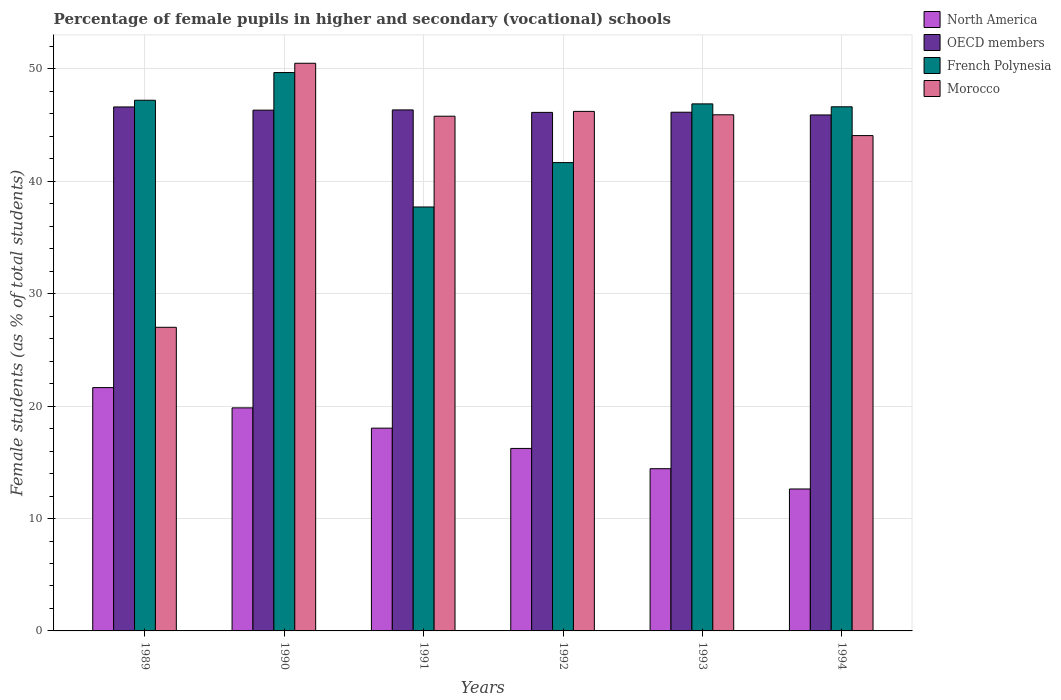How many different coloured bars are there?
Give a very brief answer. 4. How many groups of bars are there?
Make the answer very short. 6. How many bars are there on the 4th tick from the left?
Keep it short and to the point. 4. What is the percentage of female pupils in higher and secondary schools in Morocco in 1990?
Provide a short and direct response. 50.5. Across all years, what is the maximum percentage of female pupils in higher and secondary schools in Morocco?
Offer a terse response. 50.5. Across all years, what is the minimum percentage of female pupils in higher and secondary schools in OECD members?
Provide a succinct answer. 45.91. What is the total percentage of female pupils in higher and secondary schools in North America in the graph?
Your response must be concise. 102.83. What is the difference between the percentage of female pupils in higher and secondary schools in North America in 1991 and that in 1993?
Keep it short and to the point. 3.61. What is the difference between the percentage of female pupils in higher and secondary schools in North America in 1994 and the percentage of female pupils in higher and secondary schools in Morocco in 1990?
Give a very brief answer. -37.88. What is the average percentage of female pupils in higher and secondary schools in Morocco per year?
Make the answer very short. 43.25. In the year 1991, what is the difference between the percentage of female pupils in higher and secondary schools in OECD members and percentage of female pupils in higher and secondary schools in North America?
Offer a terse response. 28.31. What is the ratio of the percentage of female pupils in higher and secondary schools in French Polynesia in 1990 to that in 1993?
Provide a succinct answer. 1.06. Is the percentage of female pupils in higher and secondary schools in French Polynesia in 1990 less than that in 1991?
Your answer should be compact. No. Is the difference between the percentage of female pupils in higher and secondary schools in OECD members in 1991 and 1993 greater than the difference between the percentage of female pupils in higher and secondary schools in North America in 1991 and 1993?
Keep it short and to the point. No. What is the difference between the highest and the second highest percentage of female pupils in higher and secondary schools in Morocco?
Your answer should be very brief. 4.28. What is the difference between the highest and the lowest percentage of female pupils in higher and secondary schools in North America?
Offer a very short reply. 9.02. Is the sum of the percentage of female pupils in higher and secondary schools in OECD members in 1991 and 1994 greater than the maximum percentage of female pupils in higher and secondary schools in North America across all years?
Provide a short and direct response. Yes. What does the 4th bar from the left in 1994 represents?
Offer a very short reply. Morocco. What does the 4th bar from the right in 1993 represents?
Keep it short and to the point. North America. Are all the bars in the graph horizontal?
Provide a short and direct response. No. Where does the legend appear in the graph?
Provide a succinct answer. Top right. How are the legend labels stacked?
Offer a very short reply. Vertical. What is the title of the graph?
Give a very brief answer. Percentage of female pupils in higher and secondary (vocational) schools. Does "Malta" appear as one of the legend labels in the graph?
Provide a short and direct response. No. What is the label or title of the X-axis?
Make the answer very short. Years. What is the label or title of the Y-axis?
Keep it short and to the point. Female students (as % of total students). What is the Female students (as % of total students) in North America in 1989?
Your answer should be compact. 21.65. What is the Female students (as % of total students) in OECD members in 1989?
Provide a succinct answer. 46.62. What is the Female students (as % of total students) of French Polynesia in 1989?
Your answer should be compact. 47.21. What is the Female students (as % of total students) in Morocco in 1989?
Offer a very short reply. 27.01. What is the Female students (as % of total students) of North America in 1990?
Keep it short and to the point. 19.84. What is the Female students (as % of total students) of OECD members in 1990?
Your answer should be very brief. 46.33. What is the Female students (as % of total students) of French Polynesia in 1990?
Give a very brief answer. 49.68. What is the Female students (as % of total students) of Morocco in 1990?
Ensure brevity in your answer.  50.5. What is the Female students (as % of total students) in North America in 1991?
Ensure brevity in your answer.  18.04. What is the Female students (as % of total students) in OECD members in 1991?
Give a very brief answer. 46.35. What is the Female students (as % of total students) of French Polynesia in 1991?
Your answer should be very brief. 37.72. What is the Female students (as % of total students) of Morocco in 1991?
Keep it short and to the point. 45.79. What is the Female students (as % of total students) of North America in 1992?
Your response must be concise. 16.24. What is the Female students (as % of total students) in OECD members in 1992?
Your answer should be very brief. 46.13. What is the Female students (as % of total students) of French Polynesia in 1992?
Your response must be concise. 41.67. What is the Female students (as % of total students) in Morocco in 1992?
Your answer should be compact. 46.22. What is the Female students (as % of total students) in North America in 1993?
Provide a short and direct response. 14.43. What is the Female students (as % of total students) in OECD members in 1993?
Make the answer very short. 46.15. What is the Female students (as % of total students) in French Polynesia in 1993?
Ensure brevity in your answer.  46.89. What is the Female students (as % of total students) of Morocco in 1993?
Your answer should be compact. 45.92. What is the Female students (as % of total students) of North America in 1994?
Offer a terse response. 12.63. What is the Female students (as % of total students) in OECD members in 1994?
Your response must be concise. 45.91. What is the Female students (as % of total students) of French Polynesia in 1994?
Give a very brief answer. 46.63. What is the Female students (as % of total students) of Morocco in 1994?
Your response must be concise. 44.07. Across all years, what is the maximum Female students (as % of total students) in North America?
Your answer should be very brief. 21.65. Across all years, what is the maximum Female students (as % of total students) in OECD members?
Your response must be concise. 46.62. Across all years, what is the maximum Female students (as % of total students) of French Polynesia?
Your answer should be very brief. 49.68. Across all years, what is the maximum Female students (as % of total students) in Morocco?
Your response must be concise. 50.5. Across all years, what is the minimum Female students (as % of total students) in North America?
Offer a very short reply. 12.63. Across all years, what is the minimum Female students (as % of total students) in OECD members?
Offer a very short reply. 45.91. Across all years, what is the minimum Female students (as % of total students) in French Polynesia?
Give a very brief answer. 37.72. Across all years, what is the minimum Female students (as % of total students) in Morocco?
Offer a very short reply. 27.01. What is the total Female students (as % of total students) of North America in the graph?
Offer a very short reply. 102.83. What is the total Female students (as % of total students) in OECD members in the graph?
Your answer should be very brief. 277.49. What is the total Female students (as % of total students) in French Polynesia in the graph?
Your response must be concise. 269.8. What is the total Female students (as % of total students) in Morocco in the graph?
Provide a short and direct response. 259.53. What is the difference between the Female students (as % of total students) in North America in 1989 and that in 1990?
Your answer should be very brief. 1.8. What is the difference between the Female students (as % of total students) of OECD members in 1989 and that in 1990?
Offer a very short reply. 0.28. What is the difference between the Female students (as % of total students) in French Polynesia in 1989 and that in 1990?
Give a very brief answer. -2.46. What is the difference between the Female students (as % of total students) in Morocco in 1989 and that in 1990?
Make the answer very short. -23.49. What is the difference between the Female students (as % of total students) in North America in 1989 and that in 1991?
Your response must be concise. 3.61. What is the difference between the Female students (as % of total students) of OECD members in 1989 and that in 1991?
Your answer should be compact. 0.26. What is the difference between the Female students (as % of total students) of French Polynesia in 1989 and that in 1991?
Your response must be concise. 9.5. What is the difference between the Female students (as % of total students) in Morocco in 1989 and that in 1991?
Your response must be concise. -18.78. What is the difference between the Female students (as % of total students) in North America in 1989 and that in 1992?
Your answer should be compact. 5.41. What is the difference between the Female students (as % of total students) in OECD members in 1989 and that in 1992?
Your answer should be compact. 0.48. What is the difference between the Female students (as % of total students) in French Polynesia in 1989 and that in 1992?
Provide a short and direct response. 5.55. What is the difference between the Female students (as % of total students) of Morocco in 1989 and that in 1992?
Keep it short and to the point. -19.21. What is the difference between the Female students (as % of total students) in North America in 1989 and that in 1993?
Keep it short and to the point. 7.22. What is the difference between the Female students (as % of total students) in OECD members in 1989 and that in 1993?
Ensure brevity in your answer.  0.47. What is the difference between the Female students (as % of total students) of French Polynesia in 1989 and that in 1993?
Give a very brief answer. 0.32. What is the difference between the Female students (as % of total students) in Morocco in 1989 and that in 1993?
Offer a very short reply. -18.91. What is the difference between the Female students (as % of total students) of North America in 1989 and that in 1994?
Give a very brief answer. 9.02. What is the difference between the Female students (as % of total students) of OECD members in 1989 and that in 1994?
Give a very brief answer. 0.71. What is the difference between the Female students (as % of total students) of French Polynesia in 1989 and that in 1994?
Ensure brevity in your answer.  0.58. What is the difference between the Female students (as % of total students) of Morocco in 1989 and that in 1994?
Give a very brief answer. -17.06. What is the difference between the Female students (as % of total students) of North America in 1990 and that in 1991?
Provide a short and direct response. 1.8. What is the difference between the Female students (as % of total students) of OECD members in 1990 and that in 1991?
Give a very brief answer. -0.02. What is the difference between the Female students (as % of total students) in French Polynesia in 1990 and that in 1991?
Your answer should be compact. 11.96. What is the difference between the Female students (as % of total students) of Morocco in 1990 and that in 1991?
Offer a very short reply. 4.71. What is the difference between the Female students (as % of total students) in North America in 1990 and that in 1992?
Offer a very short reply. 3.61. What is the difference between the Female students (as % of total students) in OECD members in 1990 and that in 1992?
Offer a very short reply. 0.2. What is the difference between the Female students (as % of total students) of French Polynesia in 1990 and that in 1992?
Offer a terse response. 8.01. What is the difference between the Female students (as % of total students) of Morocco in 1990 and that in 1992?
Your answer should be very brief. 4.28. What is the difference between the Female students (as % of total students) of North America in 1990 and that in 1993?
Provide a succinct answer. 5.41. What is the difference between the Female students (as % of total students) in OECD members in 1990 and that in 1993?
Provide a succinct answer. 0.19. What is the difference between the Female students (as % of total students) of French Polynesia in 1990 and that in 1993?
Keep it short and to the point. 2.79. What is the difference between the Female students (as % of total students) of Morocco in 1990 and that in 1993?
Keep it short and to the point. 4.58. What is the difference between the Female students (as % of total students) of North America in 1990 and that in 1994?
Offer a terse response. 7.22. What is the difference between the Female students (as % of total students) of OECD members in 1990 and that in 1994?
Provide a succinct answer. 0.43. What is the difference between the Female students (as % of total students) of French Polynesia in 1990 and that in 1994?
Your response must be concise. 3.04. What is the difference between the Female students (as % of total students) in Morocco in 1990 and that in 1994?
Provide a short and direct response. 6.43. What is the difference between the Female students (as % of total students) in North America in 1991 and that in 1992?
Offer a very short reply. 1.8. What is the difference between the Female students (as % of total students) of OECD members in 1991 and that in 1992?
Ensure brevity in your answer.  0.22. What is the difference between the Female students (as % of total students) in French Polynesia in 1991 and that in 1992?
Provide a short and direct response. -3.95. What is the difference between the Female students (as % of total students) of Morocco in 1991 and that in 1992?
Offer a terse response. -0.43. What is the difference between the Female students (as % of total students) in North America in 1991 and that in 1993?
Give a very brief answer. 3.61. What is the difference between the Female students (as % of total students) of OECD members in 1991 and that in 1993?
Provide a short and direct response. 0.21. What is the difference between the Female students (as % of total students) of French Polynesia in 1991 and that in 1993?
Your answer should be compact. -9.17. What is the difference between the Female students (as % of total students) in Morocco in 1991 and that in 1993?
Provide a succinct answer. -0.13. What is the difference between the Female students (as % of total students) of North America in 1991 and that in 1994?
Make the answer very short. 5.41. What is the difference between the Female students (as % of total students) of OECD members in 1991 and that in 1994?
Your response must be concise. 0.45. What is the difference between the Female students (as % of total students) of French Polynesia in 1991 and that in 1994?
Your answer should be compact. -8.91. What is the difference between the Female students (as % of total students) in Morocco in 1991 and that in 1994?
Give a very brief answer. 1.72. What is the difference between the Female students (as % of total students) in North America in 1992 and that in 1993?
Ensure brevity in your answer.  1.8. What is the difference between the Female students (as % of total students) in OECD members in 1992 and that in 1993?
Provide a short and direct response. -0.01. What is the difference between the Female students (as % of total students) in French Polynesia in 1992 and that in 1993?
Provide a short and direct response. -5.22. What is the difference between the Female students (as % of total students) in Morocco in 1992 and that in 1993?
Your response must be concise. 0.3. What is the difference between the Female students (as % of total students) of North America in 1992 and that in 1994?
Your response must be concise. 3.61. What is the difference between the Female students (as % of total students) in OECD members in 1992 and that in 1994?
Make the answer very short. 0.23. What is the difference between the Female students (as % of total students) of French Polynesia in 1992 and that in 1994?
Give a very brief answer. -4.97. What is the difference between the Female students (as % of total students) of Morocco in 1992 and that in 1994?
Give a very brief answer. 2.15. What is the difference between the Female students (as % of total students) of North America in 1993 and that in 1994?
Keep it short and to the point. 1.8. What is the difference between the Female students (as % of total students) of OECD members in 1993 and that in 1994?
Offer a terse response. 0.24. What is the difference between the Female students (as % of total students) in French Polynesia in 1993 and that in 1994?
Keep it short and to the point. 0.26. What is the difference between the Female students (as % of total students) in Morocco in 1993 and that in 1994?
Your answer should be compact. 1.85. What is the difference between the Female students (as % of total students) of North America in 1989 and the Female students (as % of total students) of OECD members in 1990?
Provide a short and direct response. -24.68. What is the difference between the Female students (as % of total students) of North America in 1989 and the Female students (as % of total students) of French Polynesia in 1990?
Your answer should be very brief. -28.03. What is the difference between the Female students (as % of total students) in North America in 1989 and the Female students (as % of total students) in Morocco in 1990?
Provide a short and direct response. -28.86. What is the difference between the Female students (as % of total students) of OECD members in 1989 and the Female students (as % of total students) of French Polynesia in 1990?
Your response must be concise. -3.06. What is the difference between the Female students (as % of total students) in OECD members in 1989 and the Female students (as % of total students) in Morocco in 1990?
Your response must be concise. -3.89. What is the difference between the Female students (as % of total students) in French Polynesia in 1989 and the Female students (as % of total students) in Morocco in 1990?
Your answer should be very brief. -3.29. What is the difference between the Female students (as % of total students) in North America in 1989 and the Female students (as % of total students) in OECD members in 1991?
Your answer should be very brief. -24.7. What is the difference between the Female students (as % of total students) of North America in 1989 and the Female students (as % of total students) of French Polynesia in 1991?
Ensure brevity in your answer.  -16.07. What is the difference between the Female students (as % of total students) of North America in 1989 and the Female students (as % of total students) of Morocco in 1991?
Provide a short and direct response. -24.14. What is the difference between the Female students (as % of total students) of OECD members in 1989 and the Female students (as % of total students) of French Polynesia in 1991?
Ensure brevity in your answer.  8.9. What is the difference between the Female students (as % of total students) of OECD members in 1989 and the Female students (as % of total students) of Morocco in 1991?
Your answer should be compact. 0.82. What is the difference between the Female students (as % of total students) of French Polynesia in 1989 and the Female students (as % of total students) of Morocco in 1991?
Offer a terse response. 1.42. What is the difference between the Female students (as % of total students) of North America in 1989 and the Female students (as % of total students) of OECD members in 1992?
Give a very brief answer. -24.49. What is the difference between the Female students (as % of total students) in North America in 1989 and the Female students (as % of total students) in French Polynesia in 1992?
Offer a very short reply. -20.02. What is the difference between the Female students (as % of total students) in North America in 1989 and the Female students (as % of total students) in Morocco in 1992?
Your answer should be compact. -24.57. What is the difference between the Female students (as % of total students) in OECD members in 1989 and the Female students (as % of total students) in French Polynesia in 1992?
Your answer should be very brief. 4.95. What is the difference between the Female students (as % of total students) in OECD members in 1989 and the Female students (as % of total students) in Morocco in 1992?
Keep it short and to the point. 0.39. What is the difference between the Female students (as % of total students) of French Polynesia in 1989 and the Female students (as % of total students) of Morocco in 1992?
Your response must be concise. 0.99. What is the difference between the Female students (as % of total students) in North America in 1989 and the Female students (as % of total students) in OECD members in 1993?
Make the answer very short. -24.5. What is the difference between the Female students (as % of total students) of North America in 1989 and the Female students (as % of total students) of French Polynesia in 1993?
Offer a terse response. -25.24. What is the difference between the Female students (as % of total students) of North America in 1989 and the Female students (as % of total students) of Morocco in 1993?
Provide a short and direct response. -24.27. What is the difference between the Female students (as % of total students) in OECD members in 1989 and the Female students (as % of total students) in French Polynesia in 1993?
Offer a very short reply. -0.27. What is the difference between the Female students (as % of total students) in OECD members in 1989 and the Female students (as % of total students) in Morocco in 1993?
Provide a short and direct response. 0.7. What is the difference between the Female students (as % of total students) in French Polynesia in 1989 and the Female students (as % of total students) in Morocco in 1993?
Offer a very short reply. 1.29. What is the difference between the Female students (as % of total students) in North America in 1989 and the Female students (as % of total students) in OECD members in 1994?
Your answer should be very brief. -24.26. What is the difference between the Female students (as % of total students) of North America in 1989 and the Female students (as % of total students) of French Polynesia in 1994?
Keep it short and to the point. -24.98. What is the difference between the Female students (as % of total students) in North America in 1989 and the Female students (as % of total students) in Morocco in 1994?
Offer a terse response. -22.42. What is the difference between the Female students (as % of total students) of OECD members in 1989 and the Female students (as % of total students) of French Polynesia in 1994?
Your response must be concise. -0.01. What is the difference between the Female students (as % of total students) in OECD members in 1989 and the Female students (as % of total students) in Morocco in 1994?
Make the answer very short. 2.55. What is the difference between the Female students (as % of total students) in French Polynesia in 1989 and the Female students (as % of total students) in Morocco in 1994?
Provide a short and direct response. 3.14. What is the difference between the Female students (as % of total students) of North America in 1990 and the Female students (as % of total students) of OECD members in 1991?
Make the answer very short. -26.51. What is the difference between the Female students (as % of total students) of North America in 1990 and the Female students (as % of total students) of French Polynesia in 1991?
Offer a terse response. -17.87. What is the difference between the Female students (as % of total students) of North America in 1990 and the Female students (as % of total students) of Morocco in 1991?
Make the answer very short. -25.95. What is the difference between the Female students (as % of total students) of OECD members in 1990 and the Female students (as % of total students) of French Polynesia in 1991?
Your answer should be compact. 8.62. What is the difference between the Female students (as % of total students) in OECD members in 1990 and the Female students (as % of total students) in Morocco in 1991?
Make the answer very short. 0.54. What is the difference between the Female students (as % of total students) in French Polynesia in 1990 and the Female students (as % of total students) in Morocco in 1991?
Your response must be concise. 3.88. What is the difference between the Female students (as % of total students) of North America in 1990 and the Female students (as % of total students) of OECD members in 1992?
Make the answer very short. -26.29. What is the difference between the Female students (as % of total students) of North America in 1990 and the Female students (as % of total students) of French Polynesia in 1992?
Ensure brevity in your answer.  -21.82. What is the difference between the Female students (as % of total students) in North America in 1990 and the Female students (as % of total students) in Morocco in 1992?
Offer a very short reply. -26.38. What is the difference between the Female students (as % of total students) of OECD members in 1990 and the Female students (as % of total students) of French Polynesia in 1992?
Offer a terse response. 4.67. What is the difference between the Female students (as % of total students) of OECD members in 1990 and the Female students (as % of total students) of Morocco in 1992?
Your response must be concise. 0.11. What is the difference between the Female students (as % of total students) of French Polynesia in 1990 and the Female students (as % of total students) of Morocco in 1992?
Offer a very short reply. 3.45. What is the difference between the Female students (as % of total students) in North America in 1990 and the Female students (as % of total students) in OECD members in 1993?
Your response must be concise. -26.3. What is the difference between the Female students (as % of total students) in North America in 1990 and the Female students (as % of total students) in French Polynesia in 1993?
Make the answer very short. -27.05. What is the difference between the Female students (as % of total students) in North America in 1990 and the Female students (as % of total students) in Morocco in 1993?
Keep it short and to the point. -26.08. What is the difference between the Female students (as % of total students) of OECD members in 1990 and the Female students (as % of total students) of French Polynesia in 1993?
Offer a very short reply. -0.56. What is the difference between the Female students (as % of total students) in OECD members in 1990 and the Female students (as % of total students) in Morocco in 1993?
Give a very brief answer. 0.41. What is the difference between the Female students (as % of total students) of French Polynesia in 1990 and the Female students (as % of total students) of Morocco in 1993?
Offer a terse response. 3.76. What is the difference between the Female students (as % of total students) in North America in 1990 and the Female students (as % of total students) in OECD members in 1994?
Make the answer very short. -26.06. What is the difference between the Female students (as % of total students) of North America in 1990 and the Female students (as % of total students) of French Polynesia in 1994?
Your answer should be compact. -26.79. What is the difference between the Female students (as % of total students) in North America in 1990 and the Female students (as % of total students) in Morocco in 1994?
Make the answer very short. -24.23. What is the difference between the Female students (as % of total students) in OECD members in 1990 and the Female students (as % of total students) in French Polynesia in 1994?
Provide a succinct answer. -0.3. What is the difference between the Female students (as % of total students) of OECD members in 1990 and the Female students (as % of total students) of Morocco in 1994?
Ensure brevity in your answer.  2.26. What is the difference between the Female students (as % of total students) of French Polynesia in 1990 and the Female students (as % of total students) of Morocco in 1994?
Offer a terse response. 5.61. What is the difference between the Female students (as % of total students) in North America in 1991 and the Female students (as % of total students) in OECD members in 1992?
Your answer should be compact. -28.09. What is the difference between the Female students (as % of total students) in North America in 1991 and the Female students (as % of total students) in French Polynesia in 1992?
Make the answer very short. -23.63. What is the difference between the Female students (as % of total students) of North America in 1991 and the Female students (as % of total students) of Morocco in 1992?
Keep it short and to the point. -28.18. What is the difference between the Female students (as % of total students) in OECD members in 1991 and the Female students (as % of total students) in French Polynesia in 1992?
Offer a terse response. 4.69. What is the difference between the Female students (as % of total students) in OECD members in 1991 and the Female students (as % of total students) in Morocco in 1992?
Give a very brief answer. 0.13. What is the difference between the Female students (as % of total students) in French Polynesia in 1991 and the Female students (as % of total students) in Morocco in 1992?
Your answer should be compact. -8.51. What is the difference between the Female students (as % of total students) of North America in 1991 and the Female students (as % of total students) of OECD members in 1993?
Your answer should be compact. -28.11. What is the difference between the Female students (as % of total students) in North America in 1991 and the Female students (as % of total students) in French Polynesia in 1993?
Give a very brief answer. -28.85. What is the difference between the Female students (as % of total students) in North America in 1991 and the Female students (as % of total students) in Morocco in 1993?
Offer a very short reply. -27.88. What is the difference between the Female students (as % of total students) of OECD members in 1991 and the Female students (as % of total students) of French Polynesia in 1993?
Provide a short and direct response. -0.54. What is the difference between the Female students (as % of total students) of OECD members in 1991 and the Female students (as % of total students) of Morocco in 1993?
Keep it short and to the point. 0.43. What is the difference between the Female students (as % of total students) of French Polynesia in 1991 and the Female students (as % of total students) of Morocco in 1993?
Provide a short and direct response. -8.2. What is the difference between the Female students (as % of total students) of North America in 1991 and the Female students (as % of total students) of OECD members in 1994?
Your response must be concise. -27.86. What is the difference between the Female students (as % of total students) in North America in 1991 and the Female students (as % of total students) in French Polynesia in 1994?
Ensure brevity in your answer.  -28.59. What is the difference between the Female students (as % of total students) in North America in 1991 and the Female students (as % of total students) in Morocco in 1994?
Your answer should be very brief. -26.03. What is the difference between the Female students (as % of total students) of OECD members in 1991 and the Female students (as % of total students) of French Polynesia in 1994?
Your answer should be very brief. -0.28. What is the difference between the Female students (as % of total students) in OECD members in 1991 and the Female students (as % of total students) in Morocco in 1994?
Keep it short and to the point. 2.28. What is the difference between the Female students (as % of total students) in French Polynesia in 1991 and the Female students (as % of total students) in Morocco in 1994?
Provide a short and direct response. -6.35. What is the difference between the Female students (as % of total students) of North America in 1992 and the Female students (as % of total students) of OECD members in 1993?
Make the answer very short. -29.91. What is the difference between the Female students (as % of total students) of North America in 1992 and the Female students (as % of total students) of French Polynesia in 1993?
Ensure brevity in your answer.  -30.65. What is the difference between the Female students (as % of total students) in North America in 1992 and the Female students (as % of total students) in Morocco in 1993?
Offer a terse response. -29.68. What is the difference between the Female students (as % of total students) in OECD members in 1992 and the Female students (as % of total students) in French Polynesia in 1993?
Ensure brevity in your answer.  -0.76. What is the difference between the Female students (as % of total students) in OECD members in 1992 and the Female students (as % of total students) in Morocco in 1993?
Ensure brevity in your answer.  0.21. What is the difference between the Female students (as % of total students) of French Polynesia in 1992 and the Female students (as % of total students) of Morocco in 1993?
Your answer should be very brief. -4.25. What is the difference between the Female students (as % of total students) in North America in 1992 and the Female students (as % of total students) in OECD members in 1994?
Make the answer very short. -29.67. What is the difference between the Female students (as % of total students) in North America in 1992 and the Female students (as % of total students) in French Polynesia in 1994?
Provide a succinct answer. -30.4. What is the difference between the Female students (as % of total students) in North America in 1992 and the Female students (as % of total students) in Morocco in 1994?
Give a very brief answer. -27.83. What is the difference between the Female students (as % of total students) in OECD members in 1992 and the Female students (as % of total students) in French Polynesia in 1994?
Ensure brevity in your answer.  -0.5. What is the difference between the Female students (as % of total students) of OECD members in 1992 and the Female students (as % of total students) of Morocco in 1994?
Provide a succinct answer. 2.06. What is the difference between the Female students (as % of total students) of French Polynesia in 1992 and the Female students (as % of total students) of Morocco in 1994?
Keep it short and to the point. -2.4. What is the difference between the Female students (as % of total students) in North America in 1993 and the Female students (as % of total students) in OECD members in 1994?
Provide a short and direct response. -31.47. What is the difference between the Female students (as % of total students) in North America in 1993 and the Female students (as % of total students) in French Polynesia in 1994?
Offer a very short reply. -32.2. What is the difference between the Female students (as % of total students) in North America in 1993 and the Female students (as % of total students) in Morocco in 1994?
Keep it short and to the point. -29.64. What is the difference between the Female students (as % of total students) of OECD members in 1993 and the Female students (as % of total students) of French Polynesia in 1994?
Keep it short and to the point. -0.48. What is the difference between the Female students (as % of total students) of OECD members in 1993 and the Female students (as % of total students) of Morocco in 1994?
Make the answer very short. 2.08. What is the difference between the Female students (as % of total students) in French Polynesia in 1993 and the Female students (as % of total students) in Morocco in 1994?
Provide a short and direct response. 2.82. What is the average Female students (as % of total students) in North America per year?
Keep it short and to the point. 17.14. What is the average Female students (as % of total students) of OECD members per year?
Provide a succinct answer. 46.25. What is the average Female students (as % of total students) in French Polynesia per year?
Provide a short and direct response. 44.97. What is the average Female students (as % of total students) of Morocco per year?
Offer a terse response. 43.25. In the year 1989, what is the difference between the Female students (as % of total students) in North America and Female students (as % of total students) in OECD members?
Your answer should be very brief. -24.97. In the year 1989, what is the difference between the Female students (as % of total students) of North America and Female students (as % of total students) of French Polynesia?
Offer a very short reply. -25.57. In the year 1989, what is the difference between the Female students (as % of total students) in North America and Female students (as % of total students) in Morocco?
Your answer should be compact. -5.36. In the year 1989, what is the difference between the Female students (as % of total students) in OECD members and Female students (as % of total students) in French Polynesia?
Your answer should be very brief. -0.6. In the year 1989, what is the difference between the Female students (as % of total students) of OECD members and Female students (as % of total students) of Morocco?
Your response must be concise. 19.6. In the year 1989, what is the difference between the Female students (as % of total students) of French Polynesia and Female students (as % of total students) of Morocco?
Your response must be concise. 20.2. In the year 1990, what is the difference between the Female students (as % of total students) of North America and Female students (as % of total students) of OECD members?
Make the answer very short. -26.49. In the year 1990, what is the difference between the Female students (as % of total students) in North America and Female students (as % of total students) in French Polynesia?
Your answer should be very brief. -29.83. In the year 1990, what is the difference between the Female students (as % of total students) in North America and Female students (as % of total students) in Morocco?
Your response must be concise. -30.66. In the year 1990, what is the difference between the Female students (as % of total students) of OECD members and Female students (as % of total students) of French Polynesia?
Offer a terse response. -3.34. In the year 1990, what is the difference between the Female students (as % of total students) in OECD members and Female students (as % of total students) in Morocco?
Provide a succinct answer. -4.17. In the year 1990, what is the difference between the Female students (as % of total students) of French Polynesia and Female students (as % of total students) of Morocco?
Your response must be concise. -0.83. In the year 1991, what is the difference between the Female students (as % of total students) of North America and Female students (as % of total students) of OECD members?
Your response must be concise. -28.31. In the year 1991, what is the difference between the Female students (as % of total students) in North America and Female students (as % of total students) in French Polynesia?
Give a very brief answer. -19.68. In the year 1991, what is the difference between the Female students (as % of total students) of North America and Female students (as % of total students) of Morocco?
Your answer should be very brief. -27.75. In the year 1991, what is the difference between the Female students (as % of total students) of OECD members and Female students (as % of total students) of French Polynesia?
Your answer should be compact. 8.64. In the year 1991, what is the difference between the Female students (as % of total students) of OECD members and Female students (as % of total students) of Morocco?
Your answer should be compact. 0.56. In the year 1991, what is the difference between the Female students (as % of total students) in French Polynesia and Female students (as % of total students) in Morocco?
Offer a very short reply. -8.08. In the year 1992, what is the difference between the Female students (as % of total students) in North America and Female students (as % of total students) in OECD members?
Your answer should be compact. -29.9. In the year 1992, what is the difference between the Female students (as % of total students) in North America and Female students (as % of total students) in French Polynesia?
Offer a terse response. -25.43. In the year 1992, what is the difference between the Female students (as % of total students) of North America and Female students (as % of total students) of Morocco?
Keep it short and to the point. -29.99. In the year 1992, what is the difference between the Female students (as % of total students) of OECD members and Female students (as % of total students) of French Polynesia?
Your answer should be compact. 4.47. In the year 1992, what is the difference between the Female students (as % of total students) of OECD members and Female students (as % of total students) of Morocco?
Ensure brevity in your answer.  -0.09. In the year 1992, what is the difference between the Female students (as % of total students) of French Polynesia and Female students (as % of total students) of Morocco?
Keep it short and to the point. -4.56. In the year 1993, what is the difference between the Female students (as % of total students) of North America and Female students (as % of total students) of OECD members?
Your answer should be compact. -31.71. In the year 1993, what is the difference between the Female students (as % of total students) of North America and Female students (as % of total students) of French Polynesia?
Ensure brevity in your answer.  -32.46. In the year 1993, what is the difference between the Female students (as % of total students) in North America and Female students (as % of total students) in Morocco?
Make the answer very short. -31.49. In the year 1993, what is the difference between the Female students (as % of total students) in OECD members and Female students (as % of total students) in French Polynesia?
Give a very brief answer. -0.74. In the year 1993, what is the difference between the Female students (as % of total students) in OECD members and Female students (as % of total students) in Morocco?
Give a very brief answer. 0.23. In the year 1993, what is the difference between the Female students (as % of total students) of French Polynesia and Female students (as % of total students) of Morocco?
Make the answer very short. 0.97. In the year 1994, what is the difference between the Female students (as % of total students) of North America and Female students (as % of total students) of OECD members?
Offer a very short reply. -33.28. In the year 1994, what is the difference between the Female students (as % of total students) in North America and Female students (as % of total students) in French Polynesia?
Your response must be concise. -34. In the year 1994, what is the difference between the Female students (as % of total students) of North America and Female students (as % of total students) of Morocco?
Keep it short and to the point. -31.44. In the year 1994, what is the difference between the Female students (as % of total students) of OECD members and Female students (as % of total students) of French Polynesia?
Your answer should be compact. -0.73. In the year 1994, what is the difference between the Female students (as % of total students) of OECD members and Female students (as % of total students) of Morocco?
Provide a succinct answer. 1.84. In the year 1994, what is the difference between the Female students (as % of total students) in French Polynesia and Female students (as % of total students) in Morocco?
Keep it short and to the point. 2.56. What is the ratio of the Female students (as % of total students) in OECD members in 1989 to that in 1990?
Provide a short and direct response. 1.01. What is the ratio of the Female students (as % of total students) in French Polynesia in 1989 to that in 1990?
Ensure brevity in your answer.  0.95. What is the ratio of the Female students (as % of total students) in Morocco in 1989 to that in 1990?
Provide a succinct answer. 0.53. What is the ratio of the Female students (as % of total students) in French Polynesia in 1989 to that in 1991?
Offer a very short reply. 1.25. What is the ratio of the Female students (as % of total students) in Morocco in 1989 to that in 1991?
Offer a terse response. 0.59. What is the ratio of the Female students (as % of total students) of OECD members in 1989 to that in 1992?
Keep it short and to the point. 1.01. What is the ratio of the Female students (as % of total students) of French Polynesia in 1989 to that in 1992?
Offer a very short reply. 1.13. What is the ratio of the Female students (as % of total students) of Morocco in 1989 to that in 1992?
Offer a very short reply. 0.58. What is the ratio of the Female students (as % of total students) of North America in 1989 to that in 1993?
Ensure brevity in your answer.  1.5. What is the ratio of the Female students (as % of total students) of OECD members in 1989 to that in 1993?
Make the answer very short. 1.01. What is the ratio of the Female students (as % of total students) in French Polynesia in 1989 to that in 1993?
Keep it short and to the point. 1.01. What is the ratio of the Female students (as % of total students) in Morocco in 1989 to that in 1993?
Provide a succinct answer. 0.59. What is the ratio of the Female students (as % of total students) of North America in 1989 to that in 1994?
Provide a short and direct response. 1.71. What is the ratio of the Female students (as % of total students) in OECD members in 1989 to that in 1994?
Offer a terse response. 1.02. What is the ratio of the Female students (as % of total students) in French Polynesia in 1989 to that in 1994?
Offer a terse response. 1.01. What is the ratio of the Female students (as % of total students) in Morocco in 1989 to that in 1994?
Your answer should be compact. 0.61. What is the ratio of the Female students (as % of total students) in French Polynesia in 1990 to that in 1991?
Your answer should be compact. 1.32. What is the ratio of the Female students (as % of total students) of Morocco in 1990 to that in 1991?
Ensure brevity in your answer.  1.1. What is the ratio of the Female students (as % of total students) of North America in 1990 to that in 1992?
Give a very brief answer. 1.22. What is the ratio of the Female students (as % of total students) of OECD members in 1990 to that in 1992?
Offer a terse response. 1. What is the ratio of the Female students (as % of total students) in French Polynesia in 1990 to that in 1992?
Your answer should be very brief. 1.19. What is the ratio of the Female students (as % of total students) of Morocco in 1990 to that in 1992?
Your response must be concise. 1.09. What is the ratio of the Female students (as % of total students) of North America in 1990 to that in 1993?
Keep it short and to the point. 1.38. What is the ratio of the Female students (as % of total students) of French Polynesia in 1990 to that in 1993?
Give a very brief answer. 1.06. What is the ratio of the Female students (as % of total students) of Morocco in 1990 to that in 1993?
Keep it short and to the point. 1.1. What is the ratio of the Female students (as % of total students) in North America in 1990 to that in 1994?
Your answer should be compact. 1.57. What is the ratio of the Female students (as % of total students) of OECD members in 1990 to that in 1994?
Your response must be concise. 1.01. What is the ratio of the Female students (as % of total students) of French Polynesia in 1990 to that in 1994?
Your answer should be very brief. 1.07. What is the ratio of the Female students (as % of total students) in Morocco in 1990 to that in 1994?
Offer a very short reply. 1.15. What is the ratio of the Female students (as % of total students) of OECD members in 1991 to that in 1992?
Give a very brief answer. 1. What is the ratio of the Female students (as % of total students) of French Polynesia in 1991 to that in 1992?
Your answer should be compact. 0.91. What is the ratio of the Female students (as % of total students) of OECD members in 1991 to that in 1993?
Make the answer very short. 1. What is the ratio of the Female students (as % of total students) of French Polynesia in 1991 to that in 1993?
Your answer should be very brief. 0.8. What is the ratio of the Female students (as % of total students) of Morocco in 1991 to that in 1993?
Provide a succinct answer. 1. What is the ratio of the Female students (as % of total students) of North America in 1991 to that in 1994?
Provide a short and direct response. 1.43. What is the ratio of the Female students (as % of total students) in OECD members in 1991 to that in 1994?
Provide a short and direct response. 1.01. What is the ratio of the Female students (as % of total students) of French Polynesia in 1991 to that in 1994?
Ensure brevity in your answer.  0.81. What is the ratio of the Female students (as % of total students) of Morocco in 1991 to that in 1994?
Keep it short and to the point. 1.04. What is the ratio of the Female students (as % of total students) of North America in 1992 to that in 1993?
Ensure brevity in your answer.  1.12. What is the ratio of the Female students (as % of total students) in French Polynesia in 1992 to that in 1993?
Provide a short and direct response. 0.89. What is the ratio of the Female students (as % of total students) of Morocco in 1992 to that in 1993?
Offer a very short reply. 1.01. What is the ratio of the Female students (as % of total students) in OECD members in 1992 to that in 1994?
Your answer should be compact. 1. What is the ratio of the Female students (as % of total students) of French Polynesia in 1992 to that in 1994?
Ensure brevity in your answer.  0.89. What is the ratio of the Female students (as % of total students) of Morocco in 1992 to that in 1994?
Make the answer very short. 1.05. What is the ratio of the Female students (as % of total students) in North America in 1993 to that in 1994?
Ensure brevity in your answer.  1.14. What is the ratio of the Female students (as % of total students) of Morocco in 1993 to that in 1994?
Provide a short and direct response. 1.04. What is the difference between the highest and the second highest Female students (as % of total students) in North America?
Your answer should be very brief. 1.8. What is the difference between the highest and the second highest Female students (as % of total students) of OECD members?
Offer a very short reply. 0.26. What is the difference between the highest and the second highest Female students (as % of total students) of French Polynesia?
Keep it short and to the point. 2.46. What is the difference between the highest and the second highest Female students (as % of total students) in Morocco?
Your answer should be compact. 4.28. What is the difference between the highest and the lowest Female students (as % of total students) in North America?
Keep it short and to the point. 9.02. What is the difference between the highest and the lowest Female students (as % of total students) of OECD members?
Ensure brevity in your answer.  0.71. What is the difference between the highest and the lowest Female students (as % of total students) of French Polynesia?
Provide a succinct answer. 11.96. What is the difference between the highest and the lowest Female students (as % of total students) in Morocco?
Your answer should be compact. 23.49. 